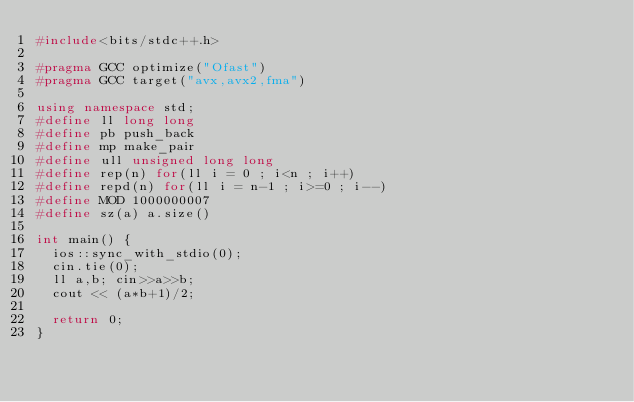Convert code to text. <code><loc_0><loc_0><loc_500><loc_500><_C++_>#include<bits/stdc++.h>

#pragma GCC optimize("Ofast")
#pragma GCC target("avx,avx2,fma")

using namespace std;
#define ll long long
#define pb push_back
#define mp make_pair
#define ull unsigned long long
#define rep(n) for(ll i = 0 ; i<n ; i++) 
#define repd(n) for(ll i = n-1 ; i>=0 ; i--)
#define MOD 1000000007
#define sz(a) a.size()

int main() {
	ios::sync_with_stdio(0);
	cin.tie(0);
	ll a,b; cin>>a>>b;
	cout << (a*b+1)/2;
	
	return 0;
}</code> 